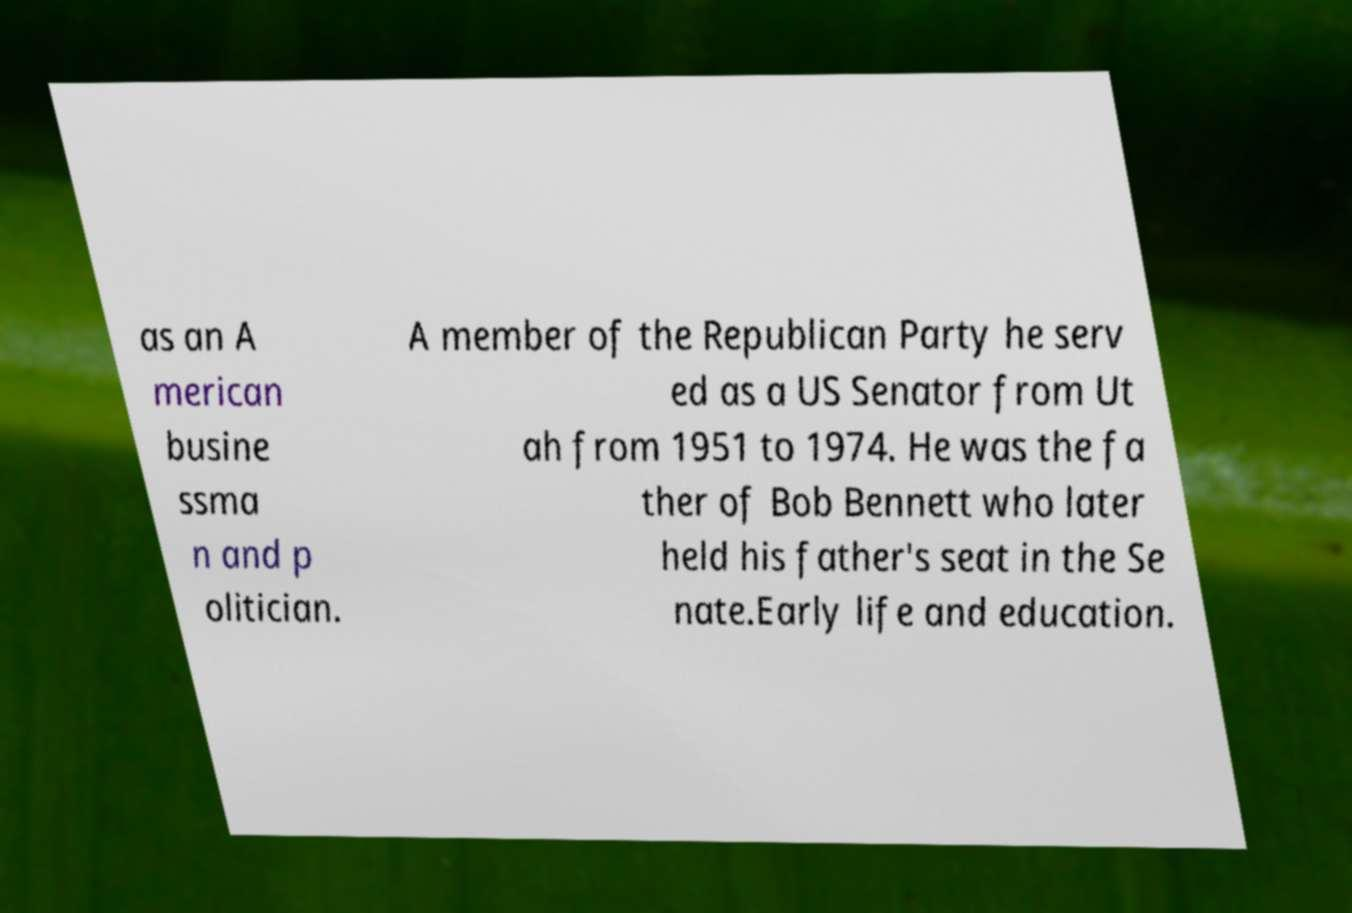Please read and relay the text visible in this image. What does it say? as an A merican busine ssma n and p olitician. A member of the Republican Party he serv ed as a US Senator from Ut ah from 1951 to 1974. He was the fa ther of Bob Bennett who later held his father's seat in the Se nate.Early life and education. 